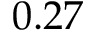<formula> <loc_0><loc_0><loc_500><loc_500>0 . 2 7</formula> 